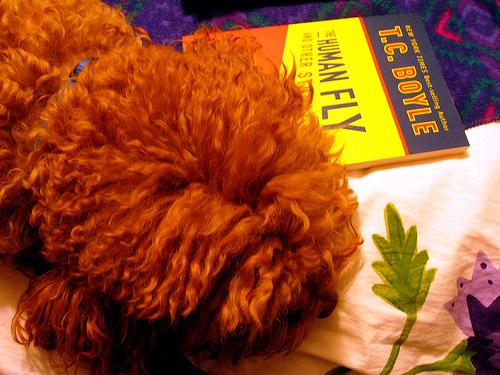Question: where is yellow?
Choices:
A. Middle of the book.
B. On the shirt.
C. Front of book.
D. The back cover.
Answer with the letter. Answer: A Question: what is the name of the book?
Choices:
A. Human Fly.
B. Clockwork Orange.
C. Wanting Seed.
D. 1984.
Answer with the letter. Answer: A Question: who has a name in the picture?
Choices:
A. Calvin Brodus.
B. William Shatner.
C. Mike Tyson.
D. T. C. Boyle.
Answer with the letter. Answer: D Question: what color is the flower?
Choices:
A. Pink.
B. Purple.
C. Red.
D. Blue.
Answer with the letter. Answer: B 